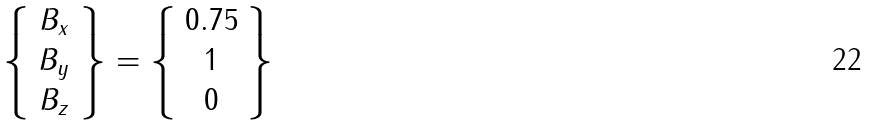<formula> <loc_0><loc_0><loc_500><loc_500>\left \{ \begin{array} { c } B _ { x } \\ B _ { y } \\ B _ { z } \end{array} \right \} = \left \{ \begin{array} { c } 0 . 7 5 \\ 1 \\ 0 \end{array} \right \}</formula> 